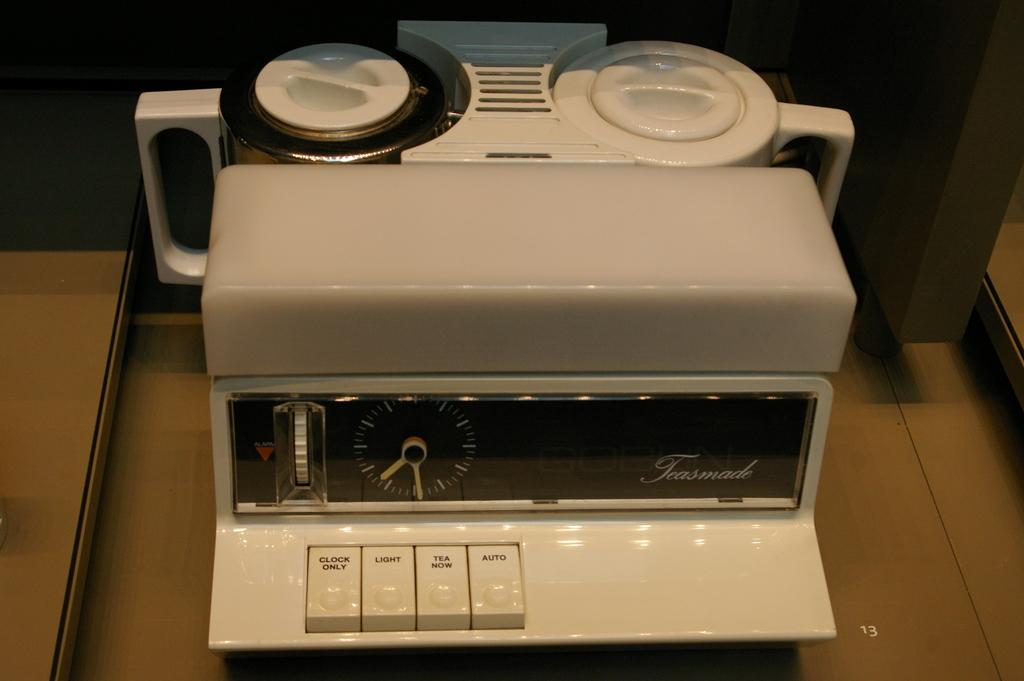<image>
Render a clear and concise summary of the photo. An old timer with the first option being clock only. 